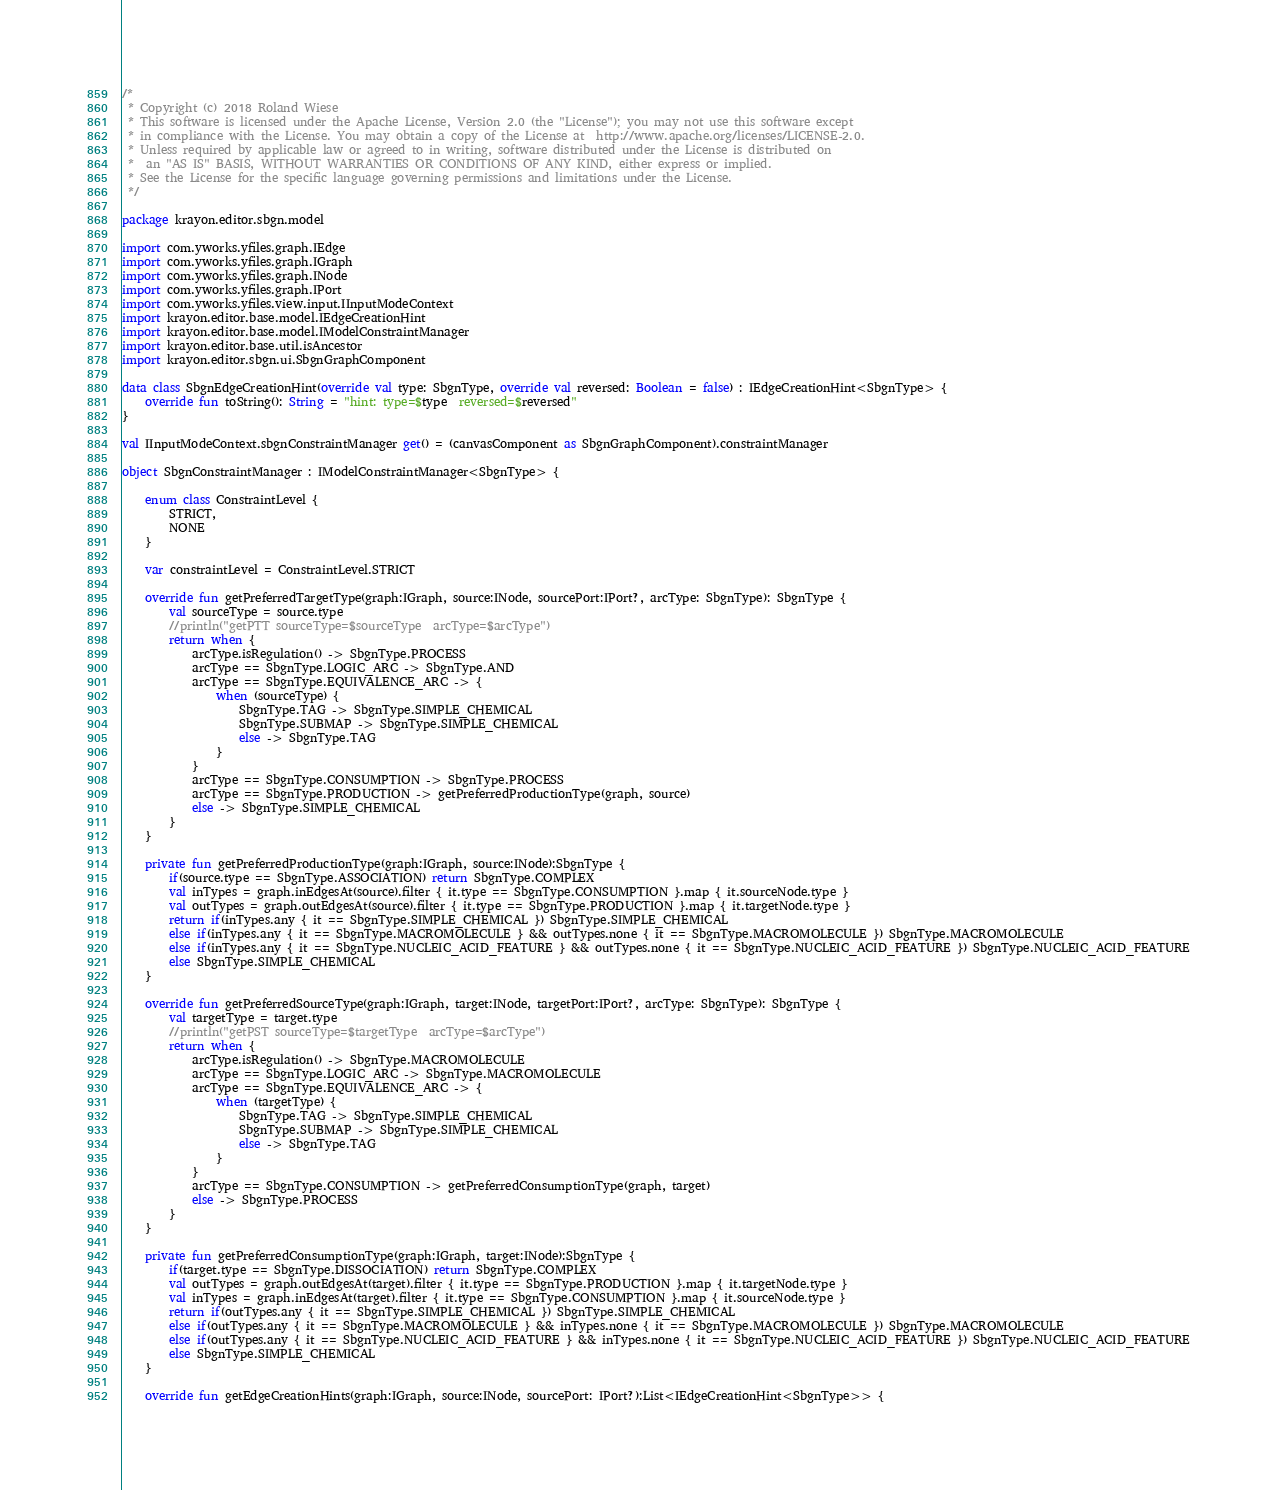Convert code to text. <code><loc_0><loc_0><loc_500><loc_500><_Kotlin_>/*
 * Copyright (c) 2018 Roland Wiese
 * This software is licensed under the Apache License, Version 2.0 (the "License"); you may not use this software except
 * in compliance with the License. You may obtain a copy of the License at  http://www.apache.org/licenses/LICENSE-2.0.
 * Unless required by applicable law or agreed to in writing, software distributed under the License is distributed on
 *  an "AS IS" BASIS, WITHOUT WARRANTIES OR CONDITIONS OF ANY KIND, either express or implied.
 * See the License for the specific language governing permissions and limitations under the License.
 */

package krayon.editor.sbgn.model

import com.yworks.yfiles.graph.IEdge
import com.yworks.yfiles.graph.IGraph
import com.yworks.yfiles.graph.INode
import com.yworks.yfiles.graph.IPort
import com.yworks.yfiles.view.input.IInputModeContext
import krayon.editor.base.model.IEdgeCreationHint
import krayon.editor.base.model.IModelConstraintManager
import krayon.editor.base.util.isAncestor
import krayon.editor.sbgn.ui.SbgnGraphComponent

data class SbgnEdgeCreationHint(override val type: SbgnType, override val reversed: Boolean = false) : IEdgeCreationHint<SbgnType> {
    override fun toString(): String = "hint: type=$type  reversed=$reversed"
}

val IInputModeContext.sbgnConstraintManager get() = (canvasComponent as SbgnGraphComponent).constraintManager

object SbgnConstraintManager : IModelConstraintManager<SbgnType> {

    enum class ConstraintLevel {
        STRICT,
        NONE
    }

    var constraintLevel = ConstraintLevel.STRICT

    override fun getPreferredTargetType(graph:IGraph, source:INode, sourcePort:IPort?, arcType: SbgnType): SbgnType {
        val sourceType = source.type
        //println("getPTT sourceType=$sourceType  arcType=$arcType")
        return when {
            arcType.isRegulation() -> SbgnType.PROCESS
            arcType == SbgnType.LOGIC_ARC -> SbgnType.AND
            arcType == SbgnType.EQUIVALENCE_ARC -> {
                when (sourceType) {
                    SbgnType.TAG -> SbgnType.SIMPLE_CHEMICAL
                    SbgnType.SUBMAP -> SbgnType.SIMPLE_CHEMICAL
                    else -> SbgnType.TAG
                }
            }
            arcType == SbgnType.CONSUMPTION -> SbgnType.PROCESS
            arcType == SbgnType.PRODUCTION -> getPreferredProductionType(graph, source)
            else -> SbgnType.SIMPLE_CHEMICAL
        }
    }

    private fun getPreferredProductionType(graph:IGraph, source:INode):SbgnType {
        if(source.type == SbgnType.ASSOCIATION) return SbgnType.COMPLEX
        val inTypes = graph.inEdgesAt(source).filter { it.type == SbgnType.CONSUMPTION }.map { it.sourceNode.type }
        val outTypes = graph.outEdgesAt(source).filter { it.type == SbgnType.PRODUCTION }.map { it.targetNode.type }
        return if(inTypes.any { it == SbgnType.SIMPLE_CHEMICAL }) SbgnType.SIMPLE_CHEMICAL
        else if(inTypes.any { it == SbgnType.MACROMOLECULE } && outTypes.none { it == SbgnType.MACROMOLECULE }) SbgnType.MACROMOLECULE
        else if(inTypes.any { it == SbgnType.NUCLEIC_ACID_FEATURE } && outTypes.none { it == SbgnType.NUCLEIC_ACID_FEATURE }) SbgnType.NUCLEIC_ACID_FEATURE
        else SbgnType.SIMPLE_CHEMICAL
    }

    override fun getPreferredSourceType(graph:IGraph, target:INode, targetPort:IPort?, arcType: SbgnType): SbgnType {
        val targetType = target.type
        //println("getPST sourceType=$targetType  arcType=$arcType")
        return when {
            arcType.isRegulation() -> SbgnType.MACROMOLECULE
            arcType == SbgnType.LOGIC_ARC -> SbgnType.MACROMOLECULE
            arcType == SbgnType.EQUIVALENCE_ARC -> {
                when (targetType) {
                    SbgnType.TAG -> SbgnType.SIMPLE_CHEMICAL
                    SbgnType.SUBMAP -> SbgnType.SIMPLE_CHEMICAL
                    else -> SbgnType.TAG
                }
            }
            arcType == SbgnType.CONSUMPTION -> getPreferredConsumptionType(graph, target)
            else -> SbgnType.PROCESS
        }
    }

    private fun getPreferredConsumptionType(graph:IGraph, target:INode):SbgnType {
        if(target.type == SbgnType.DISSOCIATION) return SbgnType.COMPLEX
        val outTypes = graph.outEdgesAt(target).filter { it.type == SbgnType.PRODUCTION }.map { it.targetNode.type }
        val inTypes = graph.inEdgesAt(target).filter { it.type == SbgnType.CONSUMPTION }.map { it.sourceNode.type }
        return if(outTypes.any { it == SbgnType.SIMPLE_CHEMICAL }) SbgnType.SIMPLE_CHEMICAL
        else if(outTypes.any { it == SbgnType.MACROMOLECULE } && inTypes.none { it == SbgnType.MACROMOLECULE }) SbgnType.MACROMOLECULE
        else if(outTypes.any { it == SbgnType.NUCLEIC_ACID_FEATURE } && inTypes.none { it == SbgnType.NUCLEIC_ACID_FEATURE }) SbgnType.NUCLEIC_ACID_FEATURE
        else SbgnType.SIMPLE_CHEMICAL
    }

    override fun getEdgeCreationHints(graph:IGraph, source:INode, sourcePort: IPort?):List<IEdgeCreationHint<SbgnType>> {</code> 